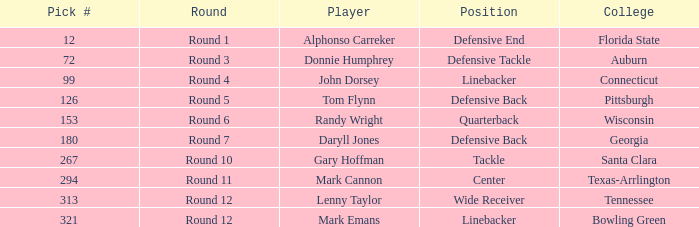Parse the full table. {'header': ['Pick #', 'Round', 'Player', 'Position', 'College'], 'rows': [['12', 'Round 1', 'Alphonso Carreker', 'Defensive End', 'Florida State'], ['72', 'Round 3', 'Donnie Humphrey', 'Defensive Tackle', 'Auburn'], ['99', 'Round 4', 'John Dorsey', 'Linebacker', 'Connecticut'], ['126', 'Round 5', 'Tom Flynn', 'Defensive Back', 'Pittsburgh'], ['153', 'Round 6', 'Randy Wright', 'Quarterback', 'Wisconsin'], ['180', 'Round 7', 'Daryll Jones', 'Defensive Back', 'Georgia'], ['267', 'Round 10', 'Gary Hoffman', 'Tackle', 'Santa Clara'], ['294', 'Round 11', 'Mark Cannon', 'Center', 'Texas-Arrlington'], ['313', 'Round 12', 'Lenny Taylor', 'Wide Receiver', 'Tennessee'], ['321', 'Round 12', 'Mark Emans', 'Linebacker', 'Bowling Green']]} Who is a wide receiver player? Lenny Taylor. 